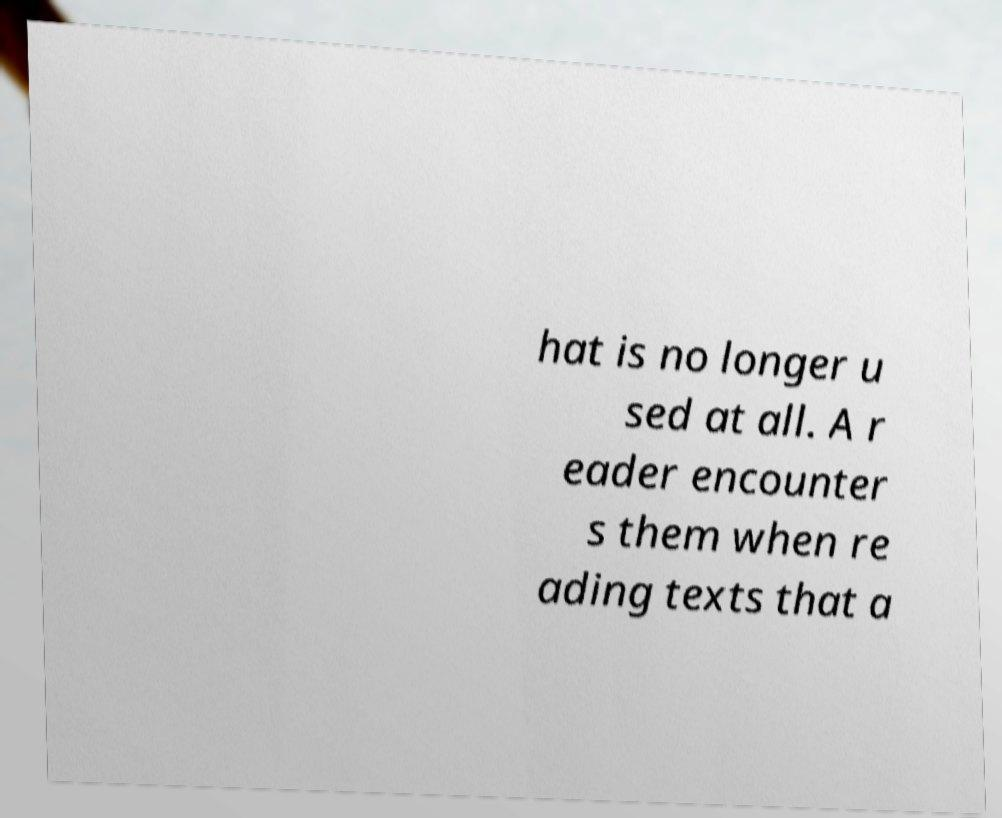Please read and relay the text visible in this image. What does it say? hat is no longer u sed at all. A r eader encounter s them when re ading texts that a 